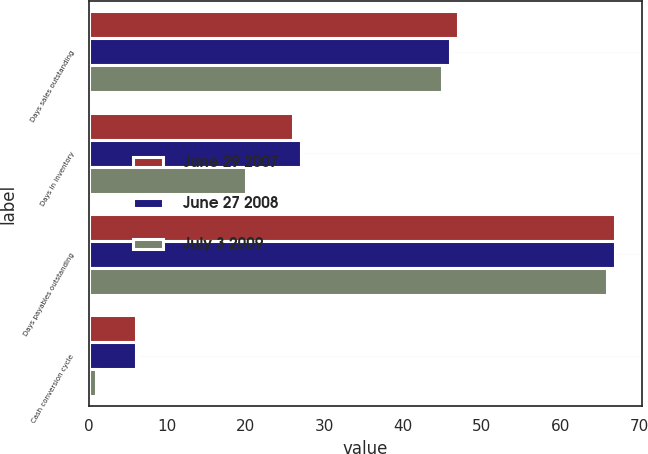Convert chart. <chart><loc_0><loc_0><loc_500><loc_500><stacked_bar_chart><ecel><fcel>Days sales outstanding<fcel>Days in inventory<fcel>Days payables outstanding<fcel>Cash conversion cycle<nl><fcel>June 29 2007<fcel>47<fcel>26<fcel>67<fcel>6<nl><fcel>June 27 2008<fcel>46<fcel>27<fcel>67<fcel>6<nl><fcel>July 3 2009<fcel>45<fcel>20<fcel>66<fcel>1<nl></chart> 